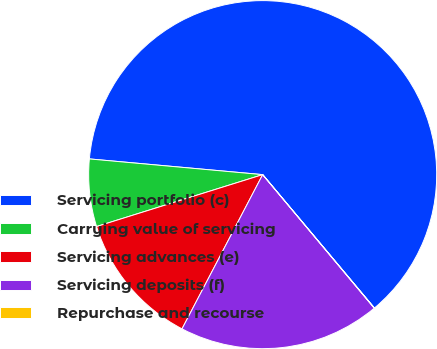Convert chart. <chart><loc_0><loc_0><loc_500><loc_500><pie_chart><fcel>Servicing portfolio (c)<fcel>Carrying value of servicing<fcel>Servicing advances (e)<fcel>Servicing deposits (f)<fcel>Repurchase and recourse<nl><fcel>62.46%<fcel>6.26%<fcel>12.51%<fcel>18.75%<fcel>0.02%<nl></chart> 